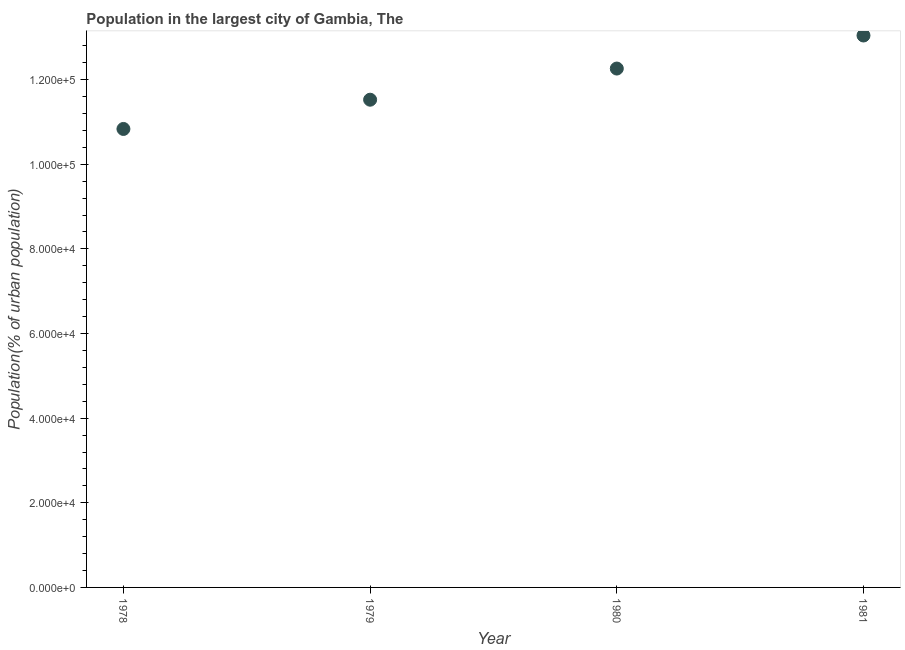What is the population in largest city in 1980?
Your answer should be compact. 1.23e+05. Across all years, what is the maximum population in largest city?
Ensure brevity in your answer.  1.30e+05. Across all years, what is the minimum population in largest city?
Offer a very short reply. 1.08e+05. In which year was the population in largest city minimum?
Your response must be concise. 1978. What is the sum of the population in largest city?
Offer a very short reply. 4.77e+05. What is the difference between the population in largest city in 1978 and 1979?
Your response must be concise. -6912. What is the average population in largest city per year?
Your response must be concise. 1.19e+05. What is the median population in largest city?
Offer a terse response. 1.19e+05. In how many years, is the population in largest city greater than 44000 %?
Provide a short and direct response. 4. What is the ratio of the population in largest city in 1980 to that in 1981?
Make the answer very short. 0.94. Is the difference between the population in largest city in 1978 and 1979 greater than the difference between any two years?
Give a very brief answer. No. What is the difference between the highest and the second highest population in largest city?
Make the answer very short. 7811. Is the sum of the population in largest city in 1980 and 1981 greater than the maximum population in largest city across all years?
Provide a succinct answer. Yes. What is the difference between the highest and the lowest population in largest city?
Your answer should be compact. 2.21e+04. How many dotlines are there?
Make the answer very short. 1. What is the difference between two consecutive major ticks on the Y-axis?
Offer a very short reply. 2.00e+04. Does the graph contain any zero values?
Your answer should be compact. No. What is the title of the graph?
Your answer should be compact. Population in the largest city of Gambia, The. What is the label or title of the X-axis?
Your answer should be very brief. Year. What is the label or title of the Y-axis?
Ensure brevity in your answer.  Population(% of urban population). What is the Population(% of urban population) in 1978?
Your response must be concise. 1.08e+05. What is the Population(% of urban population) in 1979?
Your answer should be very brief. 1.15e+05. What is the Population(% of urban population) in 1980?
Your answer should be very brief. 1.23e+05. What is the Population(% of urban population) in 1981?
Give a very brief answer. 1.30e+05. What is the difference between the Population(% of urban population) in 1978 and 1979?
Offer a very short reply. -6912. What is the difference between the Population(% of urban population) in 1978 and 1980?
Provide a short and direct response. -1.43e+04. What is the difference between the Population(% of urban population) in 1978 and 1981?
Provide a succinct answer. -2.21e+04. What is the difference between the Population(% of urban population) in 1979 and 1980?
Keep it short and to the point. -7363. What is the difference between the Population(% of urban population) in 1979 and 1981?
Provide a short and direct response. -1.52e+04. What is the difference between the Population(% of urban population) in 1980 and 1981?
Keep it short and to the point. -7811. What is the ratio of the Population(% of urban population) in 1978 to that in 1980?
Ensure brevity in your answer.  0.88. What is the ratio of the Population(% of urban population) in 1978 to that in 1981?
Your answer should be very brief. 0.83. What is the ratio of the Population(% of urban population) in 1979 to that in 1981?
Your answer should be compact. 0.88. What is the ratio of the Population(% of urban population) in 1980 to that in 1981?
Your response must be concise. 0.94. 